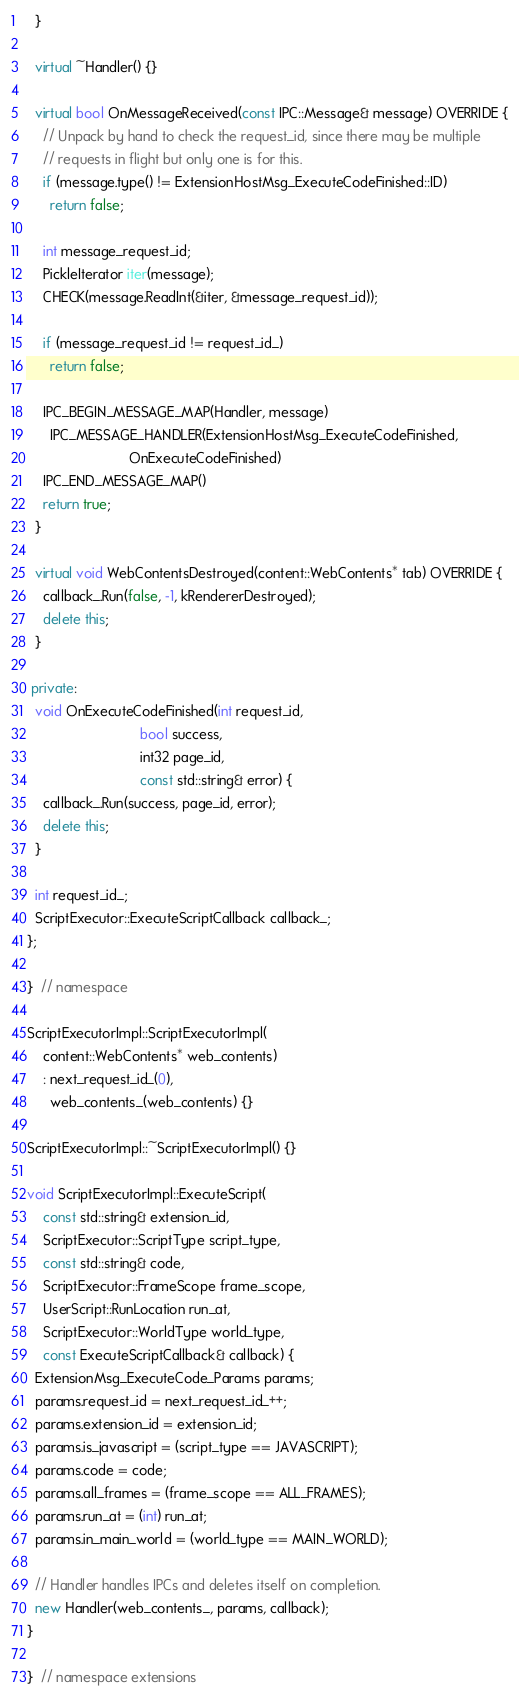<code> <loc_0><loc_0><loc_500><loc_500><_C++_>  }

  virtual ~Handler() {}

  virtual bool OnMessageReceived(const IPC::Message& message) OVERRIDE {
    // Unpack by hand to check the request_id, since there may be multiple
    // requests in flight but only one is for this.
    if (message.type() != ExtensionHostMsg_ExecuteCodeFinished::ID)
      return false;

    int message_request_id;
    PickleIterator iter(message);
    CHECK(message.ReadInt(&iter, &message_request_id));

    if (message_request_id != request_id_)
      return false;

    IPC_BEGIN_MESSAGE_MAP(Handler, message)
      IPC_MESSAGE_HANDLER(ExtensionHostMsg_ExecuteCodeFinished,
                          OnExecuteCodeFinished)
    IPC_END_MESSAGE_MAP()
    return true;
  }

  virtual void WebContentsDestroyed(content::WebContents* tab) OVERRIDE {
    callback_.Run(false, -1, kRendererDestroyed);
    delete this;
  }

 private:
  void OnExecuteCodeFinished(int request_id,
                             bool success,
                             int32 page_id,
                             const std::string& error) {
    callback_.Run(success, page_id, error);
    delete this;
  }

  int request_id_;
  ScriptExecutor::ExecuteScriptCallback callback_;
};

}  // namespace

ScriptExecutorImpl::ScriptExecutorImpl(
    content::WebContents* web_contents)
    : next_request_id_(0),
      web_contents_(web_contents) {}

ScriptExecutorImpl::~ScriptExecutorImpl() {}

void ScriptExecutorImpl::ExecuteScript(
    const std::string& extension_id,
    ScriptExecutor::ScriptType script_type,
    const std::string& code,
    ScriptExecutor::FrameScope frame_scope,
    UserScript::RunLocation run_at,
    ScriptExecutor::WorldType world_type,
    const ExecuteScriptCallback& callback) {
  ExtensionMsg_ExecuteCode_Params params;
  params.request_id = next_request_id_++;
  params.extension_id = extension_id;
  params.is_javascript = (script_type == JAVASCRIPT);
  params.code = code;
  params.all_frames = (frame_scope == ALL_FRAMES);
  params.run_at = (int) run_at;
  params.in_main_world = (world_type == MAIN_WORLD);

  // Handler handles IPCs and deletes itself on completion.
  new Handler(web_contents_, params, callback);
}

}  // namespace extensions
</code> 